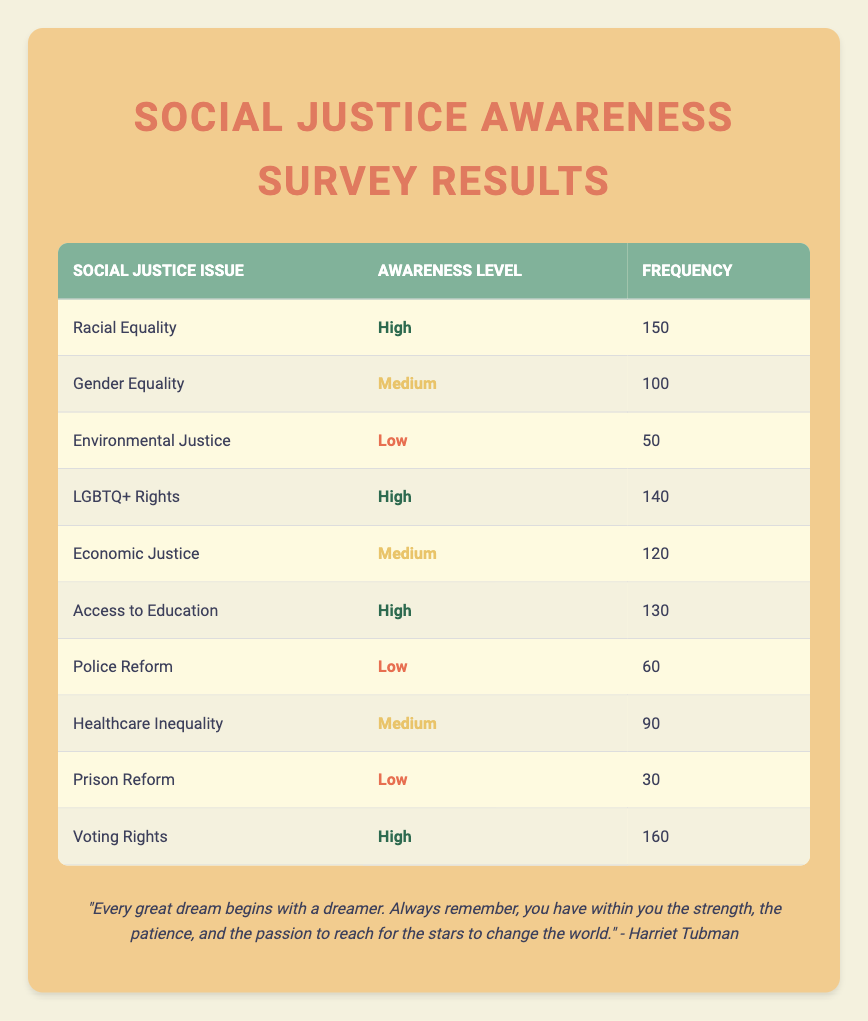What is the frequency of awareness for Racial Equality? In the table, the frequency for Racial Equality is directly listed under the frequency column for that issue. The value is 150.
Answer: 150 Which social justice issue has the highest awareness level? To find the social justice issue with the highest awareness level, we look at the awareness levels marked as High. The issues listed as High are Racial Equality, LGBTQ+ Rights, Access to Education, and Voting Rights. Among these, Voting Rights has the highest frequency of 160.
Answer: Voting Rights What is the total frequency of issues categorized as Medium awareness level? We sum the frequencies of the social justice issues categorized as Medium: Gender Equality (100), Economic Justice (120), and Healthcare Inequality (90). Therefore, the total frequency is 100 + 120 + 90 = 310.
Answer: 310 Is there any issue that has a Low awareness level with a frequency greater than 40? Looking at the Low awareness level, the issues are Environmental Justice (50), Police Reform (60), and Prison Reform (30). Since both Environmental Justice and Police Reform have frequencies greater than 40, the statement is true.
Answer: Yes What is the difference in frequency between the highest and lowest categories of awareness? The highest frequency is found in Voting Rights (160) and the lowest frequency in Prison Reform (30). To find the difference, we calculate 160 - 30, which equals 130.
Answer: 130 How many social justice issues are reported with a High awareness level? By counting the listed social justice issues with a High awareness level, we identify four: Racial Equality, LGBTQ+ Rights, Access to Education, and Voting Rights. Thus, the total count is 4.
Answer: 4 What is the average frequency of issues marked as Low awareness level? The Low awareness level includes Environmental Justice (50), Police Reform (60), and Prison Reform (30). We first sum these frequencies: 50 + 60 + 30 = 140. Since there are three issues, the average frequency is calculated as 140/3, which is approximately 46.67.
Answer: 46.67 Which social justice issue has the medium awareness level with the highest frequency? The Medium awareness level issues are Gender Equality (100), Economic Justice (120), and Healthcare Inequality (90). Among these, Economic Justice has the highest frequency of 120.
Answer: Economic Justice If we combine the frequencies of issues with High and Medium awareness levels, what total do we get? Summing the frequencies of High awareness issues (Racial Equality 150 + LGBTQ+ Rights 140 + Access to Education 130 + Voting Rights 160 = 580) and Medium awareness issues (Gender Equality 100 + Economic Justice 120 + Healthcare Inequality 90 = 310) gives us 580 + 310 = 890.
Answer: 890 